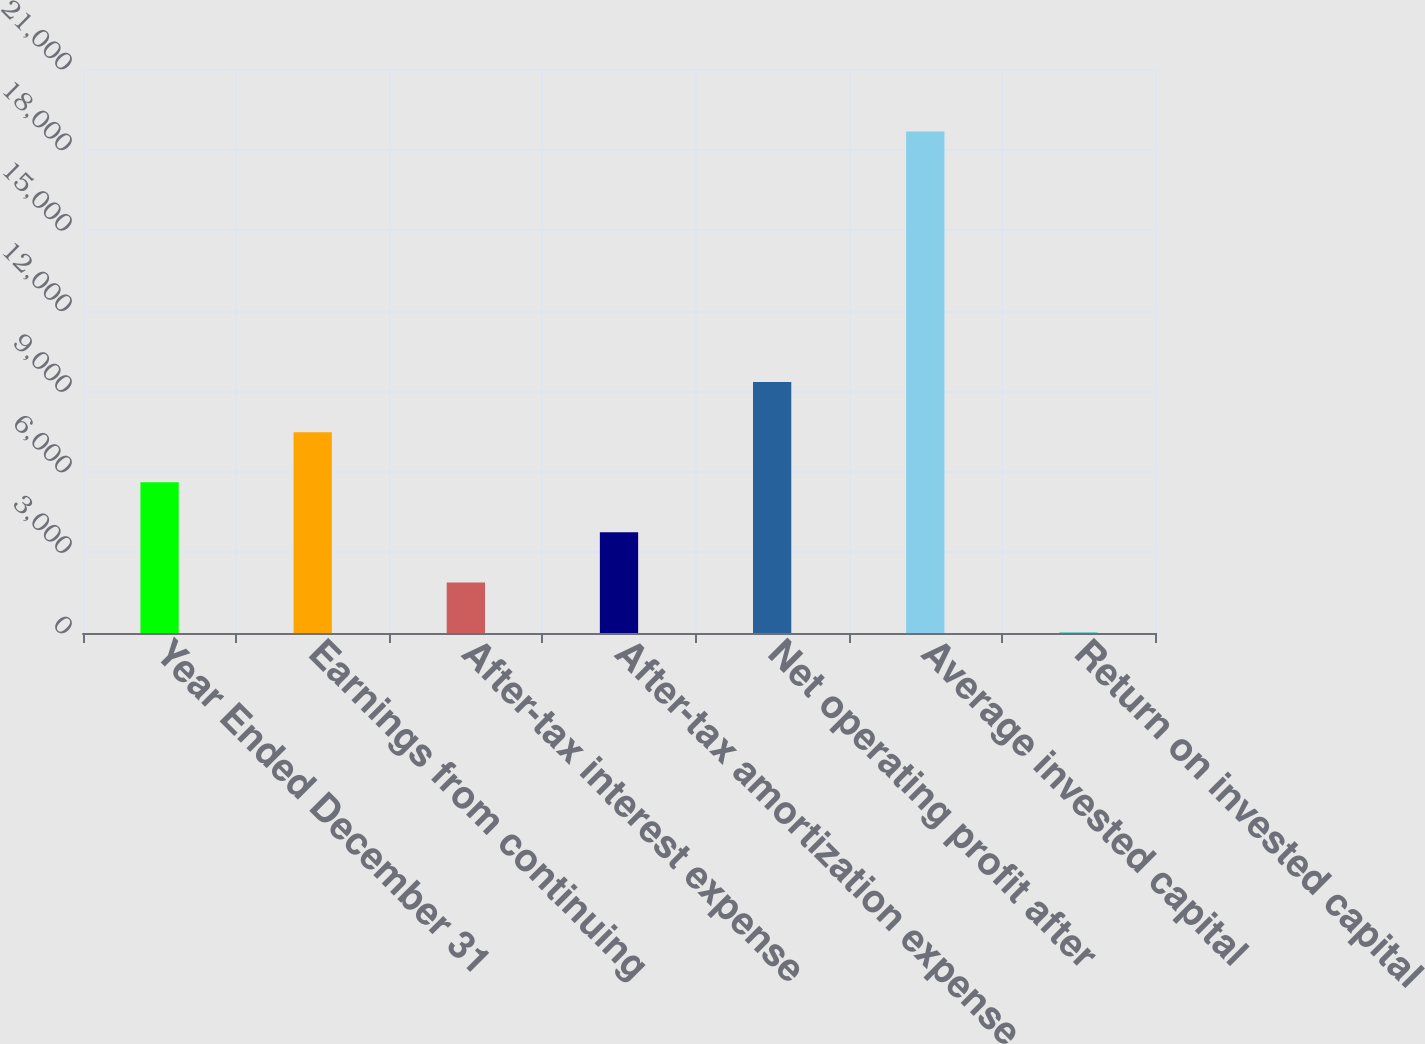Convert chart to OTSL. <chart><loc_0><loc_0><loc_500><loc_500><bar_chart><fcel>Year Ended December 31<fcel>Earnings from continuing<fcel>After-tax interest expense<fcel>After-tax amortization expense<fcel>Net operating profit after<fcel>Average invested capital<fcel>Return on invested capital<nl><fcel>5612.47<fcel>7478.26<fcel>1880.89<fcel>3746.68<fcel>9344.05<fcel>18673<fcel>15.1<nl></chart> 